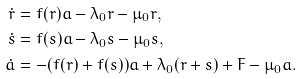Convert formula to latex. <formula><loc_0><loc_0><loc_500><loc_500>\dot { r } & = f ( r ) a - \lambda _ { 0 } r - \mu _ { 0 } r , \\ \dot { s } & = f ( s ) a - \lambda _ { 0 } s - \mu _ { 0 } s , \\ \dot { a } & = - ( f ( r ) + f ( s ) ) a + \lambda _ { 0 } ( r + s ) + F - \mu _ { 0 } a .</formula> 